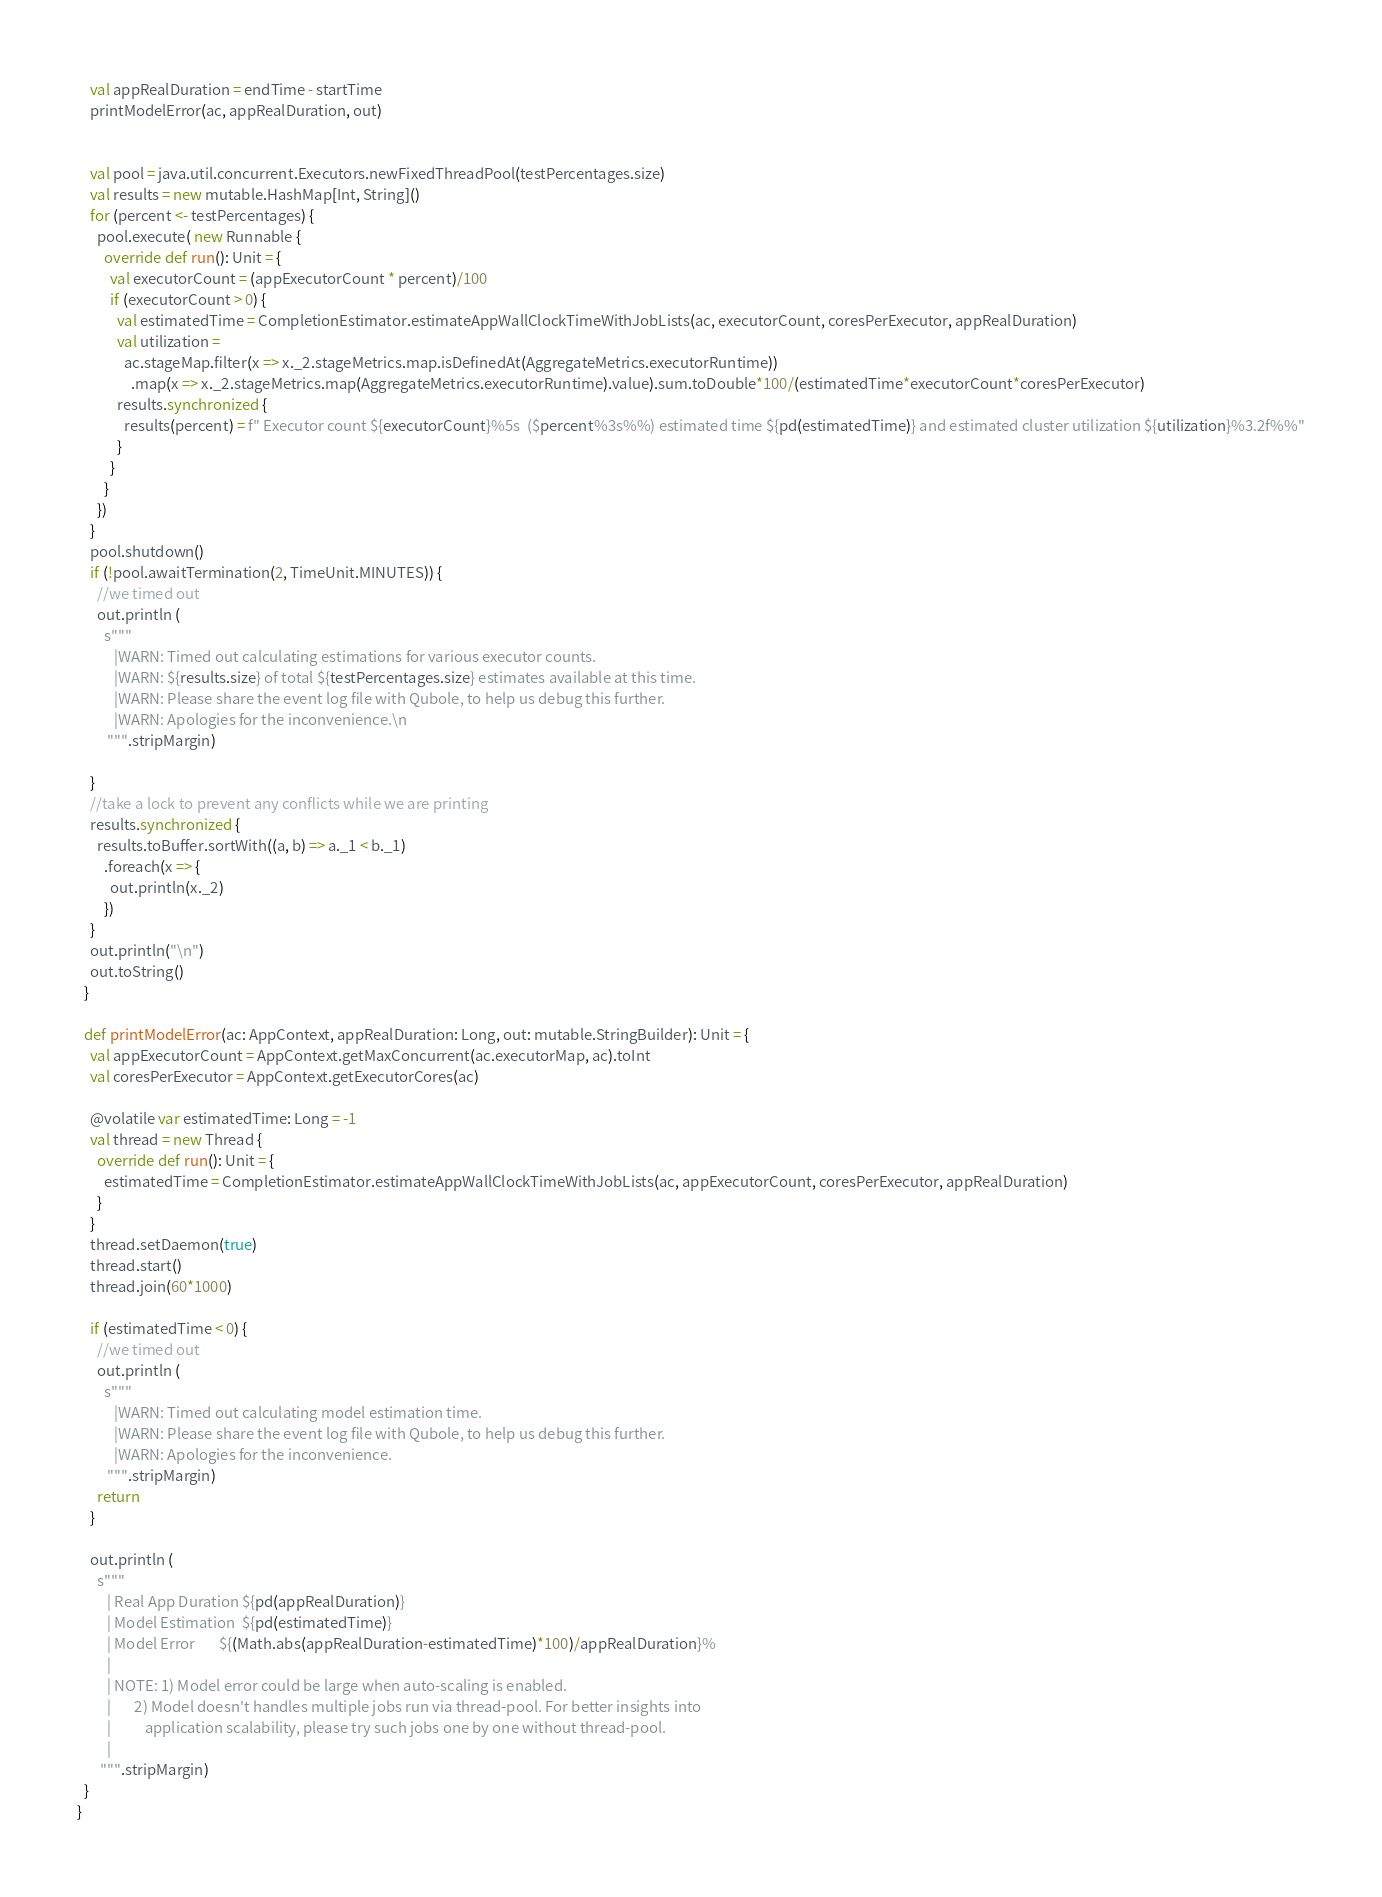Convert code to text. <code><loc_0><loc_0><loc_500><loc_500><_Scala_>    val appRealDuration = endTime - startTime
    printModelError(ac, appRealDuration, out)


    val pool = java.util.concurrent.Executors.newFixedThreadPool(testPercentages.size)
    val results = new mutable.HashMap[Int, String]()
    for (percent <- testPercentages) {
      pool.execute( new Runnable {
        override def run(): Unit = {
          val executorCount = (appExecutorCount * percent)/100
          if (executorCount > 0) {
            val estimatedTime = CompletionEstimator.estimateAppWallClockTimeWithJobLists(ac, executorCount, coresPerExecutor, appRealDuration)
            val utilization =
              ac.stageMap.filter(x => x._2.stageMetrics.map.isDefinedAt(AggregateMetrics.executorRuntime))
                .map(x => x._2.stageMetrics.map(AggregateMetrics.executorRuntime).value).sum.toDouble*100/(estimatedTime*executorCount*coresPerExecutor)
            results.synchronized {
              results(percent) = f" Executor count ${executorCount}%5s  ($percent%3s%%) estimated time ${pd(estimatedTime)} and estimated cluster utilization ${utilization}%3.2f%%"
            }
          }
        }
      })
    }
    pool.shutdown()
    if (!pool.awaitTermination(2, TimeUnit.MINUTES)) {
      //we timed out
      out.println (
        s"""
           |WARN: Timed out calculating estimations for various executor counts.
           |WARN: ${results.size} of total ${testPercentages.size} estimates available at this time.
           |WARN: Please share the event log file with Qubole, to help us debug this further.
           |WARN: Apologies for the inconvenience.\n
         """.stripMargin)

    }
    //take a lock to prevent any conflicts while we are printing
    results.synchronized {
      results.toBuffer.sortWith((a, b) => a._1 < b._1)
        .foreach(x => {
          out.println(x._2)
        })
    }
    out.println("\n")
    out.toString()
  }

  def printModelError(ac: AppContext, appRealDuration: Long, out: mutable.StringBuilder): Unit = {
    val appExecutorCount = AppContext.getMaxConcurrent(ac.executorMap, ac).toInt
    val coresPerExecutor = AppContext.getExecutorCores(ac)

    @volatile var estimatedTime: Long = -1
    val thread = new Thread {
      override def run(): Unit = {
        estimatedTime = CompletionEstimator.estimateAppWallClockTimeWithJobLists(ac, appExecutorCount, coresPerExecutor, appRealDuration)
      }
    }
    thread.setDaemon(true)
    thread.start()
    thread.join(60*1000)

    if (estimatedTime < 0) {
      //we timed out
      out.println (
        s"""
           |WARN: Timed out calculating model estimation time.
           |WARN: Please share the event log file with Qubole, to help us debug this further.
           |WARN: Apologies for the inconvenience.
         """.stripMargin)
      return
    }

    out.println (
      s"""
         | Real App Duration ${pd(appRealDuration)}
         | Model Estimation  ${pd(estimatedTime)}
         | Model Error       ${(Math.abs(appRealDuration-estimatedTime)*100)/appRealDuration}%
         |
         | NOTE: 1) Model error could be large when auto-scaling is enabled.
         |       2) Model doesn't handles multiple jobs run via thread-pool. For better insights into
         |          application scalability, please try such jobs one by one without thread-pool.
         |
       """.stripMargin)
  }
}
</code> 